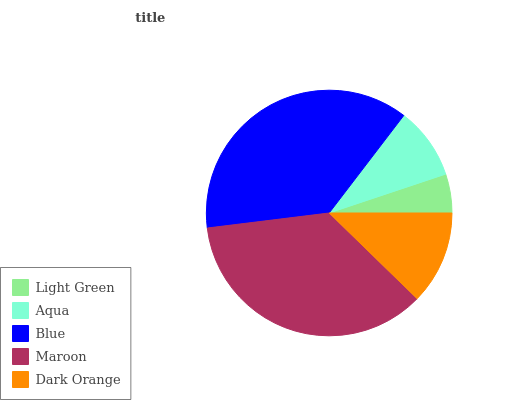Is Light Green the minimum?
Answer yes or no. Yes. Is Blue the maximum?
Answer yes or no. Yes. Is Aqua the minimum?
Answer yes or no. No. Is Aqua the maximum?
Answer yes or no. No. Is Aqua greater than Light Green?
Answer yes or no. Yes. Is Light Green less than Aqua?
Answer yes or no. Yes. Is Light Green greater than Aqua?
Answer yes or no. No. Is Aqua less than Light Green?
Answer yes or no. No. Is Dark Orange the high median?
Answer yes or no. Yes. Is Dark Orange the low median?
Answer yes or no. Yes. Is Aqua the high median?
Answer yes or no. No. Is Aqua the low median?
Answer yes or no. No. 